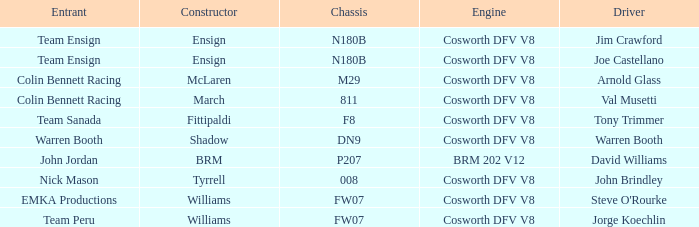Which group operated the brm assembled car? John Jordan. 